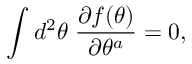Convert formula to latex. <formula><loc_0><loc_0><loc_500><loc_500>\int d ^ { 2 } \theta \, \frac { \partial f ( \theta ) } { \partial \theta ^ { a } } = 0 ,</formula> 